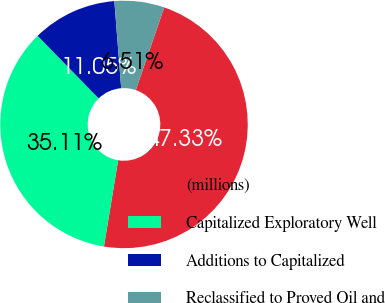Convert chart. <chart><loc_0><loc_0><loc_500><loc_500><pie_chart><fcel>(millions)<fcel>Capitalized Exploratory Well<fcel>Additions to Capitalized<fcel>Reclassified to Proved Oil and<nl><fcel>47.33%<fcel>35.11%<fcel>11.05%<fcel>6.51%<nl></chart> 